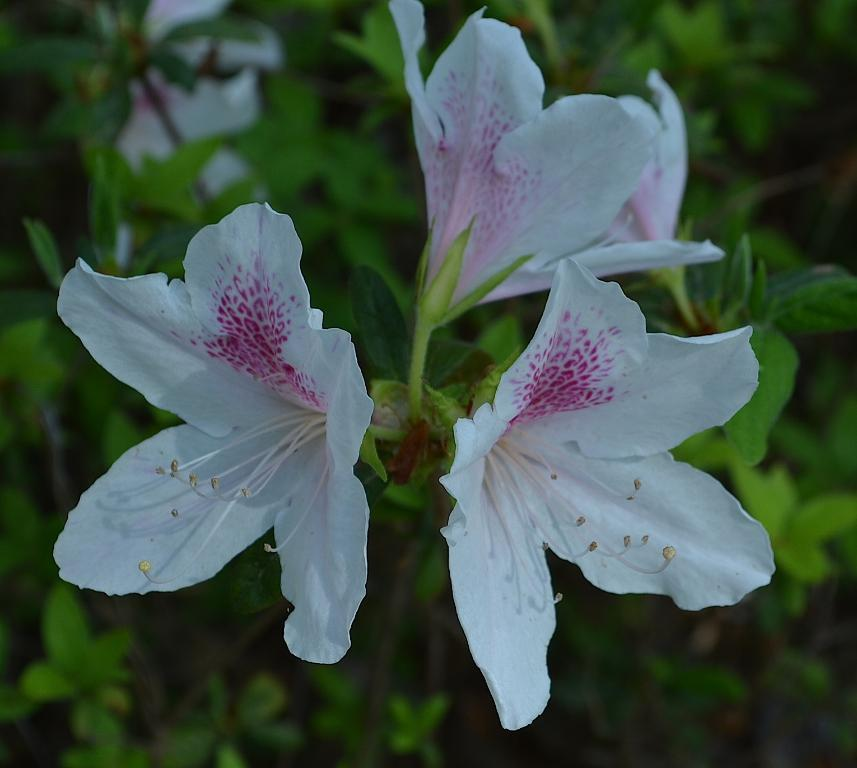What type of plants are in the image? There are flowers in the image. What colors are the flowers? The flowers are in white and pink colors. What else can be seen in the image besides the flowers? There are leaves in the image. What color are the leaves? The leaves are in green color. What type of nail is being used to fix the hospital bed in the image? There is no nail or hospital bed present in the image; it features flowers and leaves. What kind of pet can be seen playing with the flowers in the image? There is no pet present in the image; it only features flowers and leaves. 